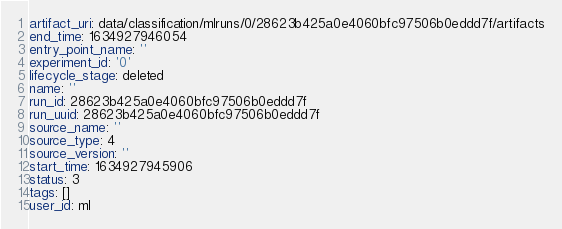Convert code to text. <code><loc_0><loc_0><loc_500><loc_500><_YAML_>artifact_uri: data/classification/mlruns/0/28623b425a0e4060bfc97506b0eddd7f/artifacts
end_time: 1634927946054
entry_point_name: ''
experiment_id: '0'
lifecycle_stage: deleted
name: ''
run_id: 28623b425a0e4060bfc97506b0eddd7f
run_uuid: 28623b425a0e4060bfc97506b0eddd7f
source_name: ''
source_type: 4
source_version: ''
start_time: 1634927945906
status: 3
tags: []
user_id: ml
</code> 